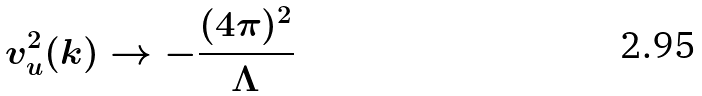<formula> <loc_0><loc_0><loc_500><loc_500>v _ { u } ^ { 2 } ( k ) \rightarrow - \frac { ( 4 \pi ) ^ { 2 } } { \Lambda }</formula> 